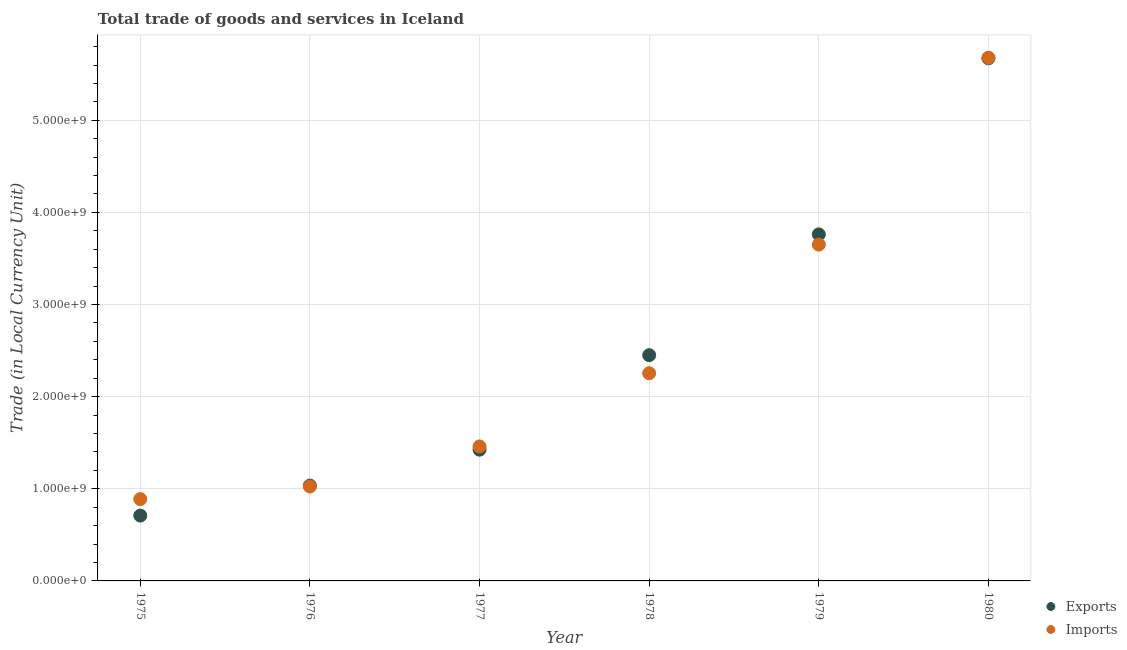What is the export of goods and services in 1978?
Keep it short and to the point. 2.45e+09. Across all years, what is the maximum imports of goods and services?
Ensure brevity in your answer.  5.68e+09. Across all years, what is the minimum imports of goods and services?
Ensure brevity in your answer.  8.88e+08. In which year was the export of goods and services minimum?
Your answer should be very brief. 1975. What is the total imports of goods and services in the graph?
Give a very brief answer. 1.50e+1. What is the difference between the imports of goods and services in 1978 and that in 1979?
Offer a very short reply. -1.40e+09. What is the difference between the imports of goods and services in 1979 and the export of goods and services in 1978?
Your answer should be very brief. 1.20e+09. What is the average export of goods and services per year?
Keep it short and to the point. 2.51e+09. In the year 1979, what is the difference between the export of goods and services and imports of goods and services?
Keep it short and to the point. 1.11e+08. What is the ratio of the export of goods and services in 1976 to that in 1979?
Your answer should be compact. 0.28. Is the imports of goods and services in 1977 less than that in 1979?
Provide a succinct answer. Yes. Is the difference between the export of goods and services in 1978 and 1980 greater than the difference between the imports of goods and services in 1978 and 1980?
Provide a succinct answer. Yes. What is the difference between the highest and the second highest imports of goods and services?
Your answer should be very brief. 2.03e+09. What is the difference between the highest and the lowest imports of goods and services?
Provide a short and direct response. 4.79e+09. Is the export of goods and services strictly less than the imports of goods and services over the years?
Your response must be concise. No. How many dotlines are there?
Keep it short and to the point. 2. Are the values on the major ticks of Y-axis written in scientific E-notation?
Provide a succinct answer. Yes. Does the graph contain any zero values?
Offer a very short reply. No. Does the graph contain grids?
Keep it short and to the point. Yes. Where does the legend appear in the graph?
Give a very brief answer. Bottom right. How are the legend labels stacked?
Keep it short and to the point. Vertical. What is the title of the graph?
Offer a terse response. Total trade of goods and services in Iceland. What is the label or title of the Y-axis?
Provide a short and direct response. Trade (in Local Currency Unit). What is the Trade (in Local Currency Unit) in Exports in 1975?
Offer a terse response. 7.09e+08. What is the Trade (in Local Currency Unit) in Imports in 1975?
Provide a short and direct response. 8.88e+08. What is the Trade (in Local Currency Unit) in Exports in 1976?
Offer a very short reply. 1.03e+09. What is the Trade (in Local Currency Unit) in Imports in 1976?
Provide a succinct answer. 1.02e+09. What is the Trade (in Local Currency Unit) in Exports in 1977?
Give a very brief answer. 1.42e+09. What is the Trade (in Local Currency Unit) of Imports in 1977?
Offer a very short reply. 1.46e+09. What is the Trade (in Local Currency Unit) of Exports in 1978?
Make the answer very short. 2.45e+09. What is the Trade (in Local Currency Unit) of Imports in 1978?
Keep it short and to the point. 2.25e+09. What is the Trade (in Local Currency Unit) of Exports in 1979?
Offer a terse response. 3.76e+09. What is the Trade (in Local Currency Unit) in Imports in 1979?
Ensure brevity in your answer.  3.65e+09. What is the Trade (in Local Currency Unit) in Exports in 1980?
Provide a short and direct response. 5.67e+09. What is the Trade (in Local Currency Unit) of Imports in 1980?
Offer a terse response. 5.68e+09. Across all years, what is the maximum Trade (in Local Currency Unit) in Exports?
Give a very brief answer. 5.67e+09. Across all years, what is the maximum Trade (in Local Currency Unit) in Imports?
Provide a short and direct response. 5.68e+09. Across all years, what is the minimum Trade (in Local Currency Unit) of Exports?
Offer a terse response. 7.09e+08. Across all years, what is the minimum Trade (in Local Currency Unit) in Imports?
Your answer should be compact. 8.88e+08. What is the total Trade (in Local Currency Unit) of Exports in the graph?
Give a very brief answer. 1.51e+1. What is the total Trade (in Local Currency Unit) of Imports in the graph?
Keep it short and to the point. 1.50e+1. What is the difference between the Trade (in Local Currency Unit) of Exports in 1975 and that in 1976?
Provide a succinct answer. -3.26e+08. What is the difference between the Trade (in Local Currency Unit) of Imports in 1975 and that in 1976?
Make the answer very short. -1.37e+08. What is the difference between the Trade (in Local Currency Unit) of Exports in 1975 and that in 1977?
Your answer should be very brief. -7.15e+08. What is the difference between the Trade (in Local Currency Unit) of Imports in 1975 and that in 1977?
Keep it short and to the point. -5.72e+08. What is the difference between the Trade (in Local Currency Unit) of Exports in 1975 and that in 1978?
Keep it short and to the point. -1.74e+09. What is the difference between the Trade (in Local Currency Unit) in Imports in 1975 and that in 1978?
Offer a terse response. -1.37e+09. What is the difference between the Trade (in Local Currency Unit) in Exports in 1975 and that in 1979?
Ensure brevity in your answer.  -3.05e+09. What is the difference between the Trade (in Local Currency Unit) of Imports in 1975 and that in 1979?
Offer a very short reply. -2.76e+09. What is the difference between the Trade (in Local Currency Unit) in Exports in 1975 and that in 1980?
Provide a short and direct response. -4.96e+09. What is the difference between the Trade (in Local Currency Unit) of Imports in 1975 and that in 1980?
Give a very brief answer. -4.79e+09. What is the difference between the Trade (in Local Currency Unit) in Exports in 1976 and that in 1977?
Your response must be concise. -3.90e+08. What is the difference between the Trade (in Local Currency Unit) in Imports in 1976 and that in 1977?
Provide a succinct answer. -4.35e+08. What is the difference between the Trade (in Local Currency Unit) of Exports in 1976 and that in 1978?
Provide a succinct answer. -1.42e+09. What is the difference between the Trade (in Local Currency Unit) in Imports in 1976 and that in 1978?
Ensure brevity in your answer.  -1.23e+09. What is the difference between the Trade (in Local Currency Unit) of Exports in 1976 and that in 1979?
Provide a succinct answer. -2.73e+09. What is the difference between the Trade (in Local Currency Unit) in Imports in 1976 and that in 1979?
Offer a terse response. -2.63e+09. What is the difference between the Trade (in Local Currency Unit) of Exports in 1976 and that in 1980?
Offer a very short reply. -4.64e+09. What is the difference between the Trade (in Local Currency Unit) of Imports in 1976 and that in 1980?
Make the answer very short. -4.65e+09. What is the difference between the Trade (in Local Currency Unit) of Exports in 1977 and that in 1978?
Provide a succinct answer. -1.03e+09. What is the difference between the Trade (in Local Currency Unit) of Imports in 1977 and that in 1978?
Offer a very short reply. -7.94e+08. What is the difference between the Trade (in Local Currency Unit) in Exports in 1977 and that in 1979?
Offer a terse response. -2.34e+09. What is the difference between the Trade (in Local Currency Unit) of Imports in 1977 and that in 1979?
Provide a short and direct response. -2.19e+09. What is the difference between the Trade (in Local Currency Unit) in Exports in 1977 and that in 1980?
Offer a very short reply. -4.25e+09. What is the difference between the Trade (in Local Currency Unit) in Imports in 1977 and that in 1980?
Make the answer very short. -4.22e+09. What is the difference between the Trade (in Local Currency Unit) in Exports in 1978 and that in 1979?
Give a very brief answer. -1.31e+09. What is the difference between the Trade (in Local Currency Unit) of Imports in 1978 and that in 1979?
Give a very brief answer. -1.40e+09. What is the difference between the Trade (in Local Currency Unit) of Exports in 1978 and that in 1980?
Ensure brevity in your answer.  -3.22e+09. What is the difference between the Trade (in Local Currency Unit) of Imports in 1978 and that in 1980?
Offer a terse response. -3.42e+09. What is the difference between the Trade (in Local Currency Unit) in Exports in 1979 and that in 1980?
Offer a terse response. -1.91e+09. What is the difference between the Trade (in Local Currency Unit) of Imports in 1979 and that in 1980?
Keep it short and to the point. -2.03e+09. What is the difference between the Trade (in Local Currency Unit) in Exports in 1975 and the Trade (in Local Currency Unit) in Imports in 1976?
Keep it short and to the point. -3.16e+08. What is the difference between the Trade (in Local Currency Unit) of Exports in 1975 and the Trade (in Local Currency Unit) of Imports in 1977?
Provide a succinct answer. -7.51e+08. What is the difference between the Trade (in Local Currency Unit) in Exports in 1975 and the Trade (in Local Currency Unit) in Imports in 1978?
Your answer should be compact. -1.54e+09. What is the difference between the Trade (in Local Currency Unit) of Exports in 1975 and the Trade (in Local Currency Unit) of Imports in 1979?
Offer a terse response. -2.94e+09. What is the difference between the Trade (in Local Currency Unit) of Exports in 1975 and the Trade (in Local Currency Unit) of Imports in 1980?
Your answer should be compact. -4.97e+09. What is the difference between the Trade (in Local Currency Unit) of Exports in 1976 and the Trade (in Local Currency Unit) of Imports in 1977?
Your response must be concise. -4.25e+08. What is the difference between the Trade (in Local Currency Unit) of Exports in 1976 and the Trade (in Local Currency Unit) of Imports in 1978?
Provide a short and direct response. -1.22e+09. What is the difference between the Trade (in Local Currency Unit) in Exports in 1976 and the Trade (in Local Currency Unit) in Imports in 1979?
Keep it short and to the point. -2.62e+09. What is the difference between the Trade (in Local Currency Unit) of Exports in 1976 and the Trade (in Local Currency Unit) of Imports in 1980?
Offer a very short reply. -4.64e+09. What is the difference between the Trade (in Local Currency Unit) in Exports in 1977 and the Trade (in Local Currency Unit) in Imports in 1978?
Provide a short and direct response. -8.30e+08. What is the difference between the Trade (in Local Currency Unit) in Exports in 1977 and the Trade (in Local Currency Unit) in Imports in 1979?
Ensure brevity in your answer.  -2.23e+09. What is the difference between the Trade (in Local Currency Unit) of Exports in 1977 and the Trade (in Local Currency Unit) of Imports in 1980?
Provide a succinct answer. -4.25e+09. What is the difference between the Trade (in Local Currency Unit) in Exports in 1978 and the Trade (in Local Currency Unit) in Imports in 1979?
Your answer should be compact. -1.20e+09. What is the difference between the Trade (in Local Currency Unit) of Exports in 1978 and the Trade (in Local Currency Unit) of Imports in 1980?
Offer a terse response. -3.23e+09. What is the difference between the Trade (in Local Currency Unit) of Exports in 1979 and the Trade (in Local Currency Unit) of Imports in 1980?
Offer a very short reply. -1.92e+09. What is the average Trade (in Local Currency Unit) in Exports per year?
Offer a very short reply. 2.51e+09. What is the average Trade (in Local Currency Unit) of Imports per year?
Your response must be concise. 2.49e+09. In the year 1975, what is the difference between the Trade (in Local Currency Unit) in Exports and Trade (in Local Currency Unit) in Imports?
Make the answer very short. -1.79e+08. In the year 1976, what is the difference between the Trade (in Local Currency Unit) in Exports and Trade (in Local Currency Unit) in Imports?
Provide a succinct answer. 1.01e+07. In the year 1977, what is the difference between the Trade (in Local Currency Unit) in Exports and Trade (in Local Currency Unit) in Imports?
Provide a succinct answer. -3.52e+07. In the year 1978, what is the difference between the Trade (in Local Currency Unit) in Exports and Trade (in Local Currency Unit) in Imports?
Provide a short and direct response. 1.96e+08. In the year 1979, what is the difference between the Trade (in Local Currency Unit) in Exports and Trade (in Local Currency Unit) in Imports?
Make the answer very short. 1.11e+08. In the year 1980, what is the difference between the Trade (in Local Currency Unit) in Exports and Trade (in Local Currency Unit) in Imports?
Your answer should be compact. -5.67e+06. What is the ratio of the Trade (in Local Currency Unit) of Exports in 1975 to that in 1976?
Ensure brevity in your answer.  0.69. What is the ratio of the Trade (in Local Currency Unit) of Imports in 1975 to that in 1976?
Offer a terse response. 0.87. What is the ratio of the Trade (in Local Currency Unit) of Exports in 1975 to that in 1977?
Provide a succinct answer. 0.5. What is the ratio of the Trade (in Local Currency Unit) of Imports in 1975 to that in 1977?
Offer a very short reply. 0.61. What is the ratio of the Trade (in Local Currency Unit) in Exports in 1975 to that in 1978?
Your answer should be compact. 0.29. What is the ratio of the Trade (in Local Currency Unit) of Imports in 1975 to that in 1978?
Your answer should be very brief. 0.39. What is the ratio of the Trade (in Local Currency Unit) of Exports in 1975 to that in 1979?
Your answer should be very brief. 0.19. What is the ratio of the Trade (in Local Currency Unit) of Imports in 1975 to that in 1979?
Your response must be concise. 0.24. What is the ratio of the Trade (in Local Currency Unit) in Exports in 1975 to that in 1980?
Offer a terse response. 0.12. What is the ratio of the Trade (in Local Currency Unit) in Imports in 1975 to that in 1980?
Ensure brevity in your answer.  0.16. What is the ratio of the Trade (in Local Currency Unit) of Exports in 1976 to that in 1977?
Provide a succinct answer. 0.73. What is the ratio of the Trade (in Local Currency Unit) in Imports in 1976 to that in 1977?
Provide a short and direct response. 0.7. What is the ratio of the Trade (in Local Currency Unit) in Exports in 1976 to that in 1978?
Keep it short and to the point. 0.42. What is the ratio of the Trade (in Local Currency Unit) of Imports in 1976 to that in 1978?
Offer a very short reply. 0.45. What is the ratio of the Trade (in Local Currency Unit) in Exports in 1976 to that in 1979?
Make the answer very short. 0.28. What is the ratio of the Trade (in Local Currency Unit) in Imports in 1976 to that in 1979?
Ensure brevity in your answer.  0.28. What is the ratio of the Trade (in Local Currency Unit) of Exports in 1976 to that in 1980?
Offer a very short reply. 0.18. What is the ratio of the Trade (in Local Currency Unit) in Imports in 1976 to that in 1980?
Your answer should be very brief. 0.18. What is the ratio of the Trade (in Local Currency Unit) in Exports in 1977 to that in 1978?
Offer a terse response. 0.58. What is the ratio of the Trade (in Local Currency Unit) in Imports in 1977 to that in 1978?
Provide a short and direct response. 0.65. What is the ratio of the Trade (in Local Currency Unit) of Exports in 1977 to that in 1979?
Your response must be concise. 0.38. What is the ratio of the Trade (in Local Currency Unit) of Imports in 1977 to that in 1979?
Offer a terse response. 0.4. What is the ratio of the Trade (in Local Currency Unit) in Exports in 1977 to that in 1980?
Your response must be concise. 0.25. What is the ratio of the Trade (in Local Currency Unit) of Imports in 1977 to that in 1980?
Your response must be concise. 0.26. What is the ratio of the Trade (in Local Currency Unit) of Exports in 1978 to that in 1979?
Your answer should be compact. 0.65. What is the ratio of the Trade (in Local Currency Unit) of Imports in 1978 to that in 1979?
Your answer should be very brief. 0.62. What is the ratio of the Trade (in Local Currency Unit) of Exports in 1978 to that in 1980?
Your response must be concise. 0.43. What is the ratio of the Trade (in Local Currency Unit) of Imports in 1978 to that in 1980?
Your answer should be very brief. 0.4. What is the ratio of the Trade (in Local Currency Unit) in Exports in 1979 to that in 1980?
Make the answer very short. 0.66. What is the ratio of the Trade (in Local Currency Unit) in Imports in 1979 to that in 1980?
Provide a short and direct response. 0.64. What is the difference between the highest and the second highest Trade (in Local Currency Unit) in Exports?
Your response must be concise. 1.91e+09. What is the difference between the highest and the second highest Trade (in Local Currency Unit) of Imports?
Provide a short and direct response. 2.03e+09. What is the difference between the highest and the lowest Trade (in Local Currency Unit) of Exports?
Your response must be concise. 4.96e+09. What is the difference between the highest and the lowest Trade (in Local Currency Unit) in Imports?
Your response must be concise. 4.79e+09. 